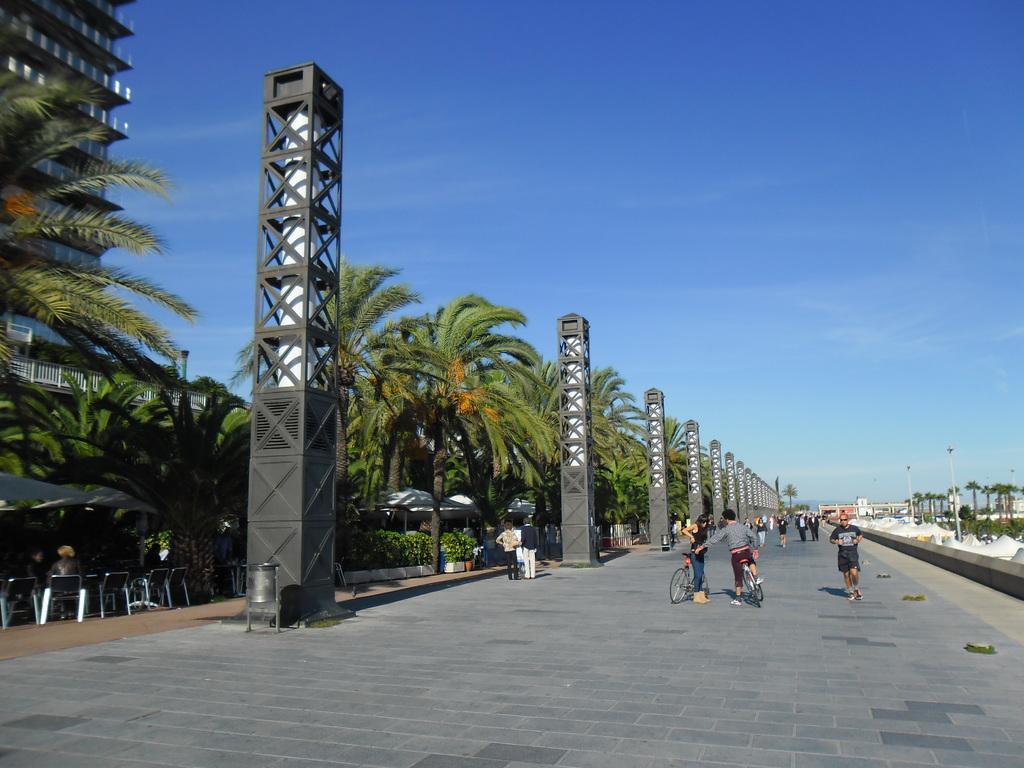Could you give a brief overview of what you see in this image? In this picture there are two person who are standing with bicycle. Beside them there is a man who is running on the street. On the left I can see many trees, umbrella, table, chairs, plants, pot, pillars and building. At the top I can see the sky and clouds. 